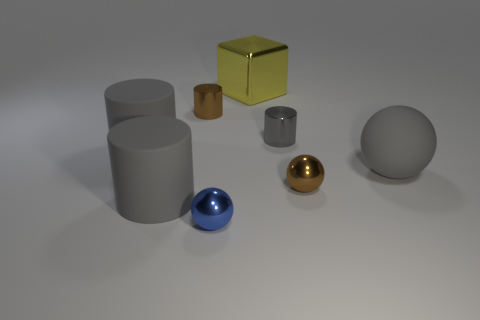How many gray cylinders must be subtracted to get 1 gray cylinders? 2 Subtract all purple blocks. How many gray cylinders are left? 3 Add 2 cylinders. How many objects exist? 10 Subtract all spheres. How many objects are left? 5 Subtract all tiny metallic cylinders. Subtract all large brown metallic cylinders. How many objects are left? 6 Add 3 metal cubes. How many metal cubes are left? 4 Add 7 yellow metallic cubes. How many yellow metallic cubes exist? 8 Subtract 0 gray blocks. How many objects are left? 8 